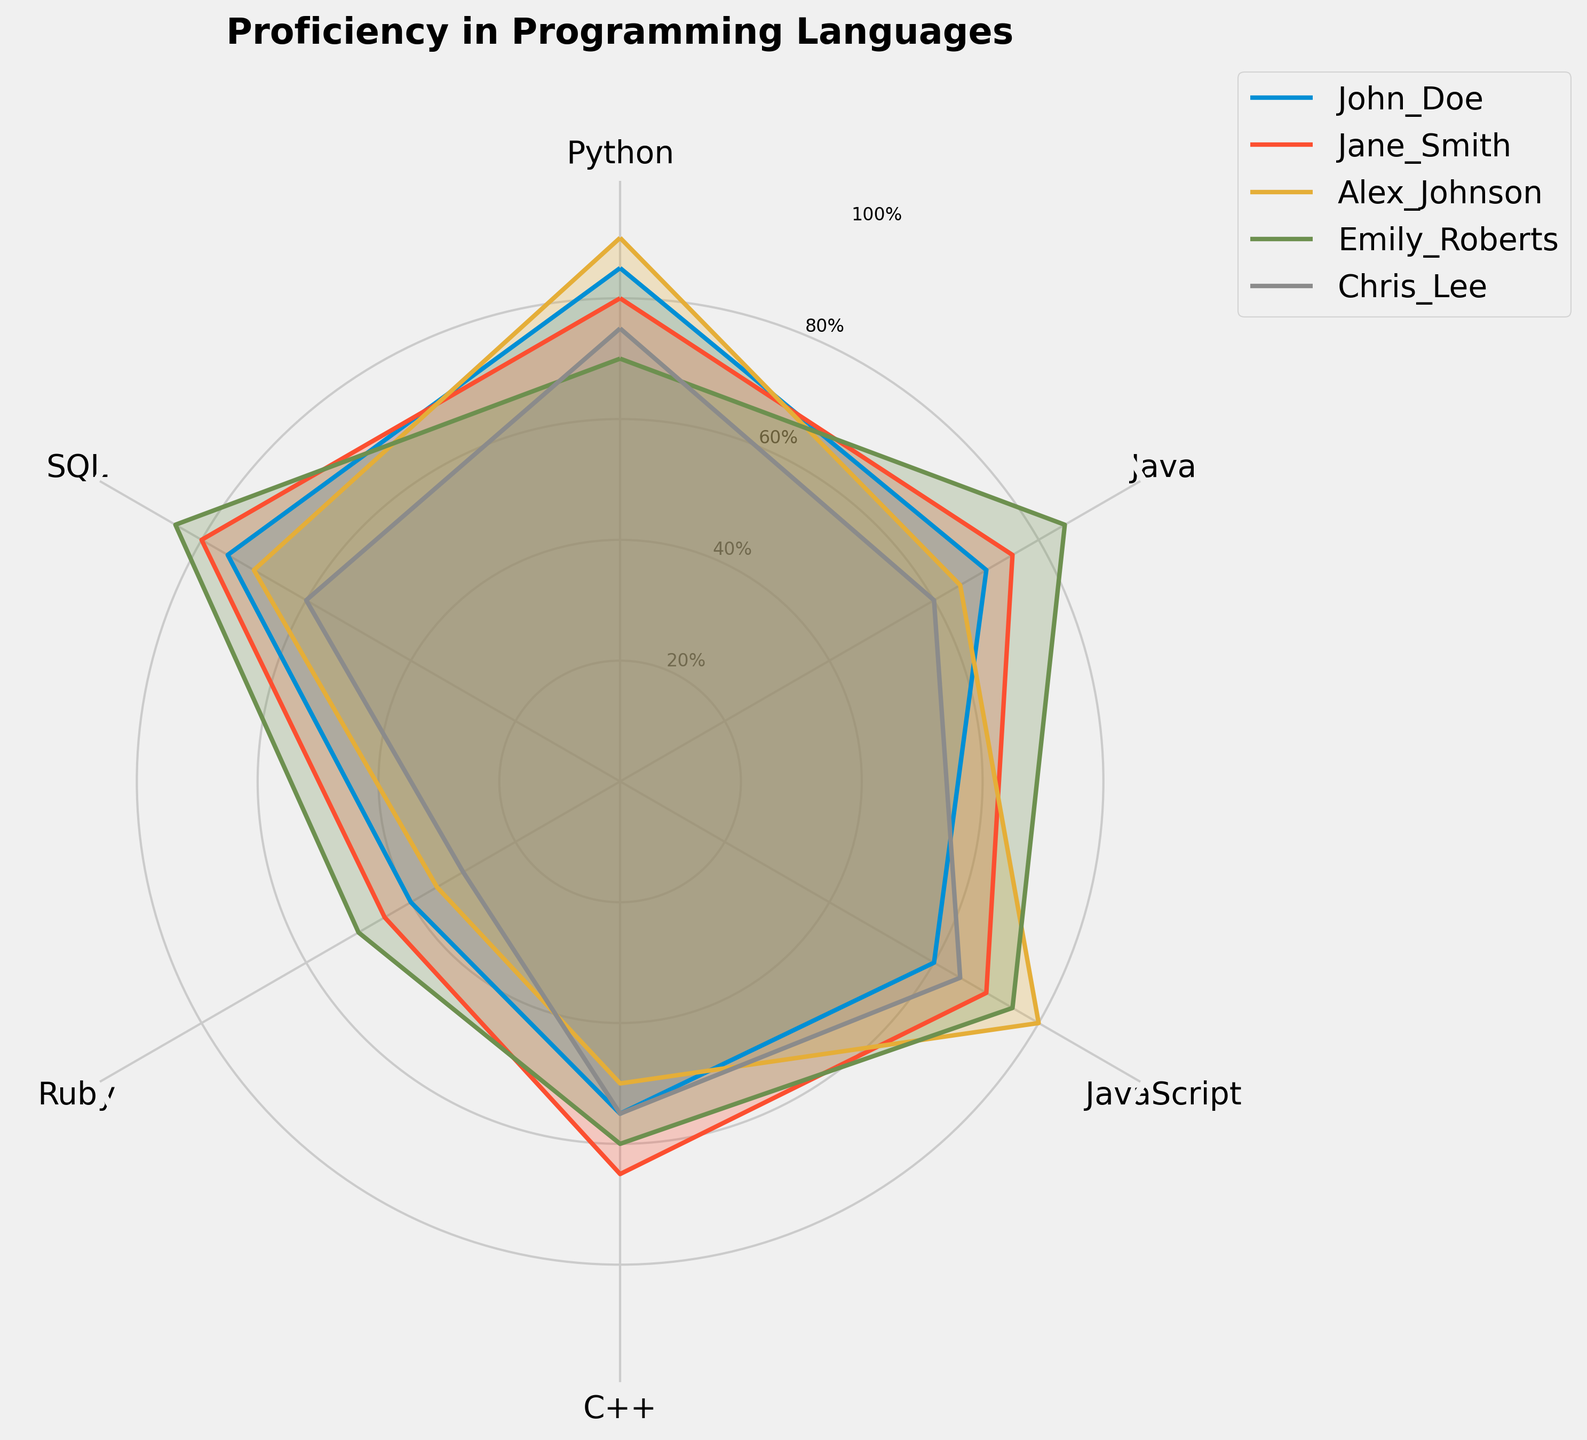What's the title of the figure? The title is displayed at the top of the radar chart and often gives an overview of what the chart represents.
Answer: "Proficiency in Programming Languages" Which programming language has the highest proficiency for John Doe? To find the highest proficiency for John Doe, look at the outermost point on John Doe's line in the radar chart.
Answer: Python (85) Who has the lowest proficiency in Ruby? To find who has the lowest proficiency, look at the smallest value for Ruby and identify which student it belongs to.
Answer: Chris Lee (30) What's the average proficiency in SQL across all students? Sum the SQL values for all students (75 + 80 + 70 + 85 + 60) which equals 370, then divide by the number of students 5.
Answer: 74 Which two students have the largest proficiency difference in Java? Compare the Java proficiencies and find the two students with the maximum difference, which is between Emily Roberts (85) and Chris Lee (60).
Answer: Emily Roberts and Chris Lee (difference is 25) What is Emily Roberts' proficiency in C++ and how does it compare to her proficiency in Python? Locate Emily Roberts' proficiency values for both C++ and Python, then compare them. Her C++ proficiency is 60, while her Python proficiency is 70, showing a 10-point higher proficiency in Python.
Answer: 60, 10 points higher in Python Which student has the most consistent proficiency across all programming languages? Consistency can be measured by the smallest range (difference between highest and lowest value) across all languages. Calculate ranges (max - min) for each student and identify the smallest one. Alex Johnson: 90-50=40, John Doe: 85-40=45, Jane Smith: 80-45=35, Emily Roberts: 85-50=35, Chris Lee: 75-30=45. Jane Smith and Emily Roberts both have a range of 35.
Answer: Jane Smith and Emily Roberts Rank John Doe's proficiency in all programming languages from highest to lowest. List the proficiency values for John Doe and sort them in descending order: Python (85), SQL (75), Java (70), JavaScript (60), C++ (55), Ruby (40).
Answer: Python, SQL, Java, JavaScript, C++, Ruby 